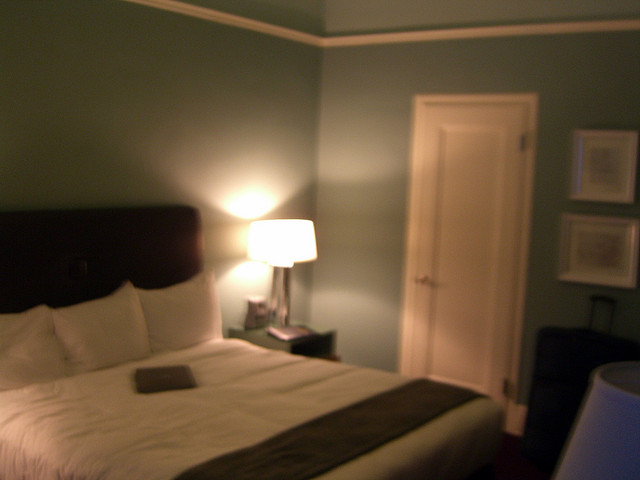<image>What is in the framed photo on right wall? It is unknown what is in the framed photo on the right wall. It could be a picture, art, flower, person or sketch. Could you see the TV by laying in bed? It is ambiguous to determine whether you could see the TV by laying in bed. What is in the framed photo on right wall? I am not sure what is in the framed photo on the right wall. It can be a picture, art, flower, person or sketch. Could you see the TV by laying in bed? I don't know if you can see the TV by laying in bed. It can vary depending on the position and height of the TV. 